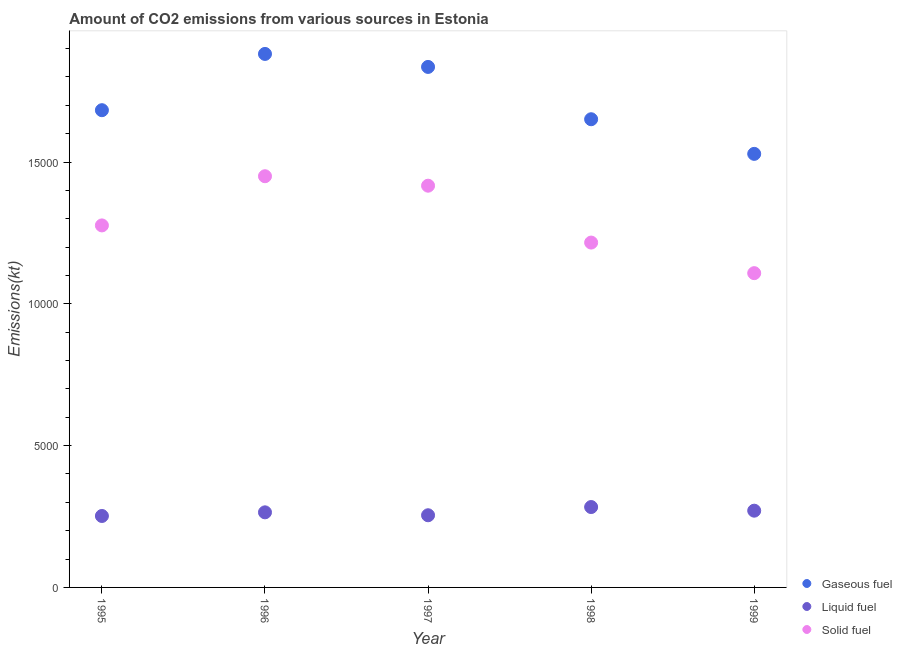What is the amount of co2 emissions from solid fuel in 1998?
Your answer should be very brief. 1.22e+04. Across all years, what is the maximum amount of co2 emissions from gaseous fuel?
Offer a very short reply. 1.88e+04. Across all years, what is the minimum amount of co2 emissions from gaseous fuel?
Make the answer very short. 1.53e+04. In which year was the amount of co2 emissions from liquid fuel maximum?
Offer a terse response. 1998. In which year was the amount of co2 emissions from gaseous fuel minimum?
Your response must be concise. 1999. What is the total amount of co2 emissions from liquid fuel in the graph?
Ensure brevity in your answer.  1.33e+04. What is the difference between the amount of co2 emissions from liquid fuel in 1995 and that in 1998?
Your response must be concise. -315.36. What is the difference between the amount of co2 emissions from liquid fuel in 1999 and the amount of co2 emissions from gaseous fuel in 1998?
Ensure brevity in your answer.  -1.38e+04. What is the average amount of co2 emissions from liquid fuel per year?
Your answer should be very brief. 2650.51. In the year 1997, what is the difference between the amount of co2 emissions from gaseous fuel and amount of co2 emissions from liquid fuel?
Your response must be concise. 1.58e+04. In how many years, is the amount of co2 emissions from liquid fuel greater than 8000 kt?
Your response must be concise. 0. What is the ratio of the amount of co2 emissions from liquid fuel in 1995 to that in 1996?
Offer a terse response. 0.95. Is the difference between the amount of co2 emissions from solid fuel in 1996 and 1999 greater than the difference between the amount of co2 emissions from gaseous fuel in 1996 and 1999?
Offer a very short reply. No. What is the difference between the highest and the second highest amount of co2 emissions from gaseous fuel?
Keep it short and to the point. 458.38. What is the difference between the highest and the lowest amount of co2 emissions from liquid fuel?
Give a very brief answer. 315.36. In how many years, is the amount of co2 emissions from liquid fuel greater than the average amount of co2 emissions from liquid fuel taken over all years?
Give a very brief answer. 2. Does the amount of co2 emissions from solid fuel monotonically increase over the years?
Keep it short and to the point. No. Is the amount of co2 emissions from liquid fuel strictly less than the amount of co2 emissions from solid fuel over the years?
Ensure brevity in your answer.  Yes. Are the values on the major ticks of Y-axis written in scientific E-notation?
Offer a terse response. No. Where does the legend appear in the graph?
Your response must be concise. Bottom right. How are the legend labels stacked?
Your response must be concise. Vertical. What is the title of the graph?
Keep it short and to the point. Amount of CO2 emissions from various sources in Estonia. Does "Resident buildings and public services" appear as one of the legend labels in the graph?
Offer a very short reply. No. What is the label or title of the Y-axis?
Keep it short and to the point. Emissions(kt). What is the Emissions(kt) of Gaseous fuel in 1995?
Your answer should be very brief. 1.68e+04. What is the Emissions(kt) of Liquid fuel in 1995?
Give a very brief answer. 2519.23. What is the Emissions(kt) in Solid fuel in 1995?
Offer a terse response. 1.28e+04. What is the Emissions(kt) of Gaseous fuel in 1996?
Your answer should be very brief. 1.88e+04. What is the Emissions(kt) in Liquid fuel in 1996?
Make the answer very short. 2647.57. What is the Emissions(kt) of Solid fuel in 1996?
Offer a very short reply. 1.45e+04. What is the Emissions(kt) in Gaseous fuel in 1997?
Make the answer very short. 1.84e+04. What is the Emissions(kt) of Liquid fuel in 1997?
Your answer should be compact. 2544.9. What is the Emissions(kt) in Solid fuel in 1997?
Provide a succinct answer. 1.42e+04. What is the Emissions(kt) of Gaseous fuel in 1998?
Provide a succinct answer. 1.65e+04. What is the Emissions(kt) of Liquid fuel in 1998?
Provide a succinct answer. 2834.59. What is the Emissions(kt) of Solid fuel in 1998?
Offer a very short reply. 1.22e+04. What is the Emissions(kt) of Gaseous fuel in 1999?
Make the answer very short. 1.53e+04. What is the Emissions(kt) in Liquid fuel in 1999?
Your answer should be compact. 2706.25. What is the Emissions(kt) in Solid fuel in 1999?
Offer a very short reply. 1.11e+04. Across all years, what is the maximum Emissions(kt) of Gaseous fuel?
Offer a very short reply. 1.88e+04. Across all years, what is the maximum Emissions(kt) of Liquid fuel?
Provide a succinct answer. 2834.59. Across all years, what is the maximum Emissions(kt) of Solid fuel?
Offer a very short reply. 1.45e+04. Across all years, what is the minimum Emissions(kt) in Gaseous fuel?
Your response must be concise. 1.53e+04. Across all years, what is the minimum Emissions(kt) in Liquid fuel?
Your answer should be very brief. 2519.23. Across all years, what is the minimum Emissions(kt) of Solid fuel?
Keep it short and to the point. 1.11e+04. What is the total Emissions(kt) of Gaseous fuel in the graph?
Make the answer very short. 8.58e+04. What is the total Emissions(kt) in Liquid fuel in the graph?
Your answer should be compact. 1.33e+04. What is the total Emissions(kt) in Solid fuel in the graph?
Provide a succinct answer. 6.47e+04. What is the difference between the Emissions(kt) of Gaseous fuel in 1995 and that in 1996?
Offer a terse response. -1983.85. What is the difference between the Emissions(kt) in Liquid fuel in 1995 and that in 1996?
Your response must be concise. -128.34. What is the difference between the Emissions(kt) in Solid fuel in 1995 and that in 1996?
Ensure brevity in your answer.  -1734.49. What is the difference between the Emissions(kt) in Gaseous fuel in 1995 and that in 1997?
Offer a very short reply. -1525.47. What is the difference between the Emissions(kt) of Liquid fuel in 1995 and that in 1997?
Offer a very short reply. -25.67. What is the difference between the Emissions(kt) of Solid fuel in 1995 and that in 1997?
Keep it short and to the point. -1400.79. What is the difference between the Emissions(kt) of Gaseous fuel in 1995 and that in 1998?
Ensure brevity in your answer.  319.03. What is the difference between the Emissions(kt) in Liquid fuel in 1995 and that in 1998?
Your response must be concise. -315.36. What is the difference between the Emissions(kt) of Solid fuel in 1995 and that in 1998?
Your answer should be very brief. 605.05. What is the difference between the Emissions(kt) of Gaseous fuel in 1995 and that in 1999?
Offer a terse response. 1540.14. What is the difference between the Emissions(kt) of Liquid fuel in 1995 and that in 1999?
Provide a succinct answer. -187.02. What is the difference between the Emissions(kt) in Solid fuel in 1995 and that in 1999?
Your answer should be compact. 1683.15. What is the difference between the Emissions(kt) in Gaseous fuel in 1996 and that in 1997?
Keep it short and to the point. 458.38. What is the difference between the Emissions(kt) of Liquid fuel in 1996 and that in 1997?
Provide a succinct answer. 102.68. What is the difference between the Emissions(kt) of Solid fuel in 1996 and that in 1997?
Ensure brevity in your answer.  333.7. What is the difference between the Emissions(kt) of Gaseous fuel in 1996 and that in 1998?
Provide a succinct answer. 2302.88. What is the difference between the Emissions(kt) in Liquid fuel in 1996 and that in 1998?
Make the answer very short. -187.02. What is the difference between the Emissions(kt) in Solid fuel in 1996 and that in 1998?
Offer a terse response. 2339.55. What is the difference between the Emissions(kt) of Gaseous fuel in 1996 and that in 1999?
Your response must be concise. 3523.99. What is the difference between the Emissions(kt) in Liquid fuel in 1996 and that in 1999?
Your response must be concise. -58.67. What is the difference between the Emissions(kt) in Solid fuel in 1996 and that in 1999?
Provide a succinct answer. 3417.64. What is the difference between the Emissions(kt) of Gaseous fuel in 1997 and that in 1998?
Your answer should be very brief. 1844.5. What is the difference between the Emissions(kt) in Liquid fuel in 1997 and that in 1998?
Provide a short and direct response. -289.69. What is the difference between the Emissions(kt) of Solid fuel in 1997 and that in 1998?
Give a very brief answer. 2005.85. What is the difference between the Emissions(kt) of Gaseous fuel in 1997 and that in 1999?
Your response must be concise. 3065.61. What is the difference between the Emissions(kt) in Liquid fuel in 1997 and that in 1999?
Ensure brevity in your answer.  -161.35. What is the difference between the Emissions(kt) in Solid fuel in 1997 and that in 1999?
Your answer should be compact. 3083.95. What is the difference between the Emissions(kt) in Gaseous fuel in 1998 and that in 1999?
Offer a terse response. 1221.11. What is the difference between the Emissions(kt) of Liquid fuel in 1998 and that in 1999?
Your answer should be very brief. 128.34. What is the difference between the Emissions(kt) of Solid fuel in 1998 and that in 1999?
Make the answer very short. 1078.1. What is the difference between the Emissions(kt) in Gaseous fuel in 1995 and the Emissions(kt) in Liquid fuel in 1996?
Give a very brief answer. 1.42e+04. What is the difference between the Emissions(kt) of Gaseous fuel in 1995 and the Emissions(kt) of Solid fuel in 1996?
Make the answer very short. 2328.55. What is the difference between the Emissions(kt) of Liquid fuel in 1995 and the Emissions(kt) of Solid fuel in 1996?
Your answer should be very brief. -1.20e+04. What is the difference between the Emissions(kt) of Gaseous fuel in 1995 and the Emissions(kt) of Liquid fuel in 1997?
Your response must be concise. 1.43e+04. What is the difference between the Emissions(kt) of Gaseous fuel in 1995 and the Emissions(kt) of Solid fuel in 1997?
Keep it short and to the point. 2662.24. What is the difference between the Emissions(kt) in Liquid fuel in 1995 and the Emissions(kt) in Solid fuel in 1997?
Your answer should be very brief. -1.16e+04. What is the difference between the Emissions(kt) in Gaseous fuel in 1995 and the Emissions(kt) in Liquid fuel in 1998?
Your response must be concise. 1.40e+04. What is the difference between the Emissions(kt) of Gaseous fuel in 1995 and the Emissions(kt) of Solid fuel in 1998?
Give a very brief answer. 4668.09. What is the difference between the Emissions(kt) in Liquid fuel in 1995 and the Emissions(kt) in Solid fuel in 1998?
Offer a terse response. -9640.54. What is the difference between the Emissions(kt) in Gaseous fuel in 1995 and the Emissions(kt) in Liquid fuel in 1999?
Your response must be concise. 1.41e+04. What is the difference between the Emissions(kt) of Gaseous fuel in 1995 and the Emissions(kt) of Solid fuel in 1999?
Keep it short and to the point. 5746.19. What is the difference between the Emissions(kt) in Liquid fuel in 1995 and the Emissions(kt) in Solid fuel in 1999?
Your answer should be very brief. -8562.44. What is the difference between the Emissions(kt) of Gaseous fuel in 1996 and the Emissions(kt) of Liquid fuel in 1997?
Your response must be concise. 1.63e+04. What is the difference between the Emissions(kt) of Gaseous fuel in 1996 and the Emissions(kt) of Solid fuel in 1997?
Your response must be concise. 4646.09. What is the difference between the Emissions(kt) of Liquid fuel in 1996 and the Emissions(kt) of Solid fuel in 1997?
Your answer should be compact. -1.15e+04. What is the difference between the Emissions(kt) of Gaseous fuel in 1996 and the Emissions(kt) of Liquid fuel in 1998?
Provide a succinct answer. 1.60e+04. What is the difference between the Emissions(kt) in Gaseous fuel in 1996 and the Emissions(kt) in Solid fuel in 1998?
Ensure brevity in your answer.  6651.94. What is the difference between the Emissions(kt) of Liquid fuel in 1996 and the Emissions(kt) of Solid fuel in 1998?
Give a very brief answer. -9512.2. What is the difference between the Emissions(kt) in Gaseous fuel in 1996 and the Emissions(kt) in Liquid fuel in 1999?
Keep it short and to the point. 1.61e+04. What is the difference between the Emissions(kt) in Gaseous fuel in 1996 and the Emissions(kt) in Solid fuel in 1999?
Provide a succinct answer. 7730.04. What is the difference between the Emissions(kt) in Liquid fuel in 1996 and the Emissions(kt) in Solid fuel in 1999?
Give a very brief answer. -8434.1. What is the difference between the Emissions(kt) of Gaseous fuel in 1997 and the Emissions(kt) of Liquid fuel in 1998?
Your response must be concise. 1.55e+04. What is the difference between the Emissions(kt) of Gaseous fuel in 1997 and the Emissions(kt) of Solid fuel in 1998?
Give a very brief answer. 6193.56. What is the difference between the Emissions(kt) in Liquid fuel in 1997 and the Emissions(kt) in Solid fuel in 1998?
Your answer should be compact. -9614.87. What is the difference between the Emissions(kt) of Gaseous fuel in 1997 and the Emissions(kt) of Liquid fuel in 1999?
Keep it short and to the point. 1.56e+04. What is the difference between the Emissions(kt) of Gaseous fuel in 1997 and the Emissions(kt) of Solid fuel in 1999?
Give a very brief answer. 7271.66. What is the difference between the Emissions(kt) of Liquid fuel in 1997 and the Emissions(kt) of Solid fuel in 1999?
Make the answer very short. -8536.78. What is the difference between the Emissions(kt) in Gaseous fuel in 1998 and the Emissions(kt) in Liquid fuel in 1999?
Offer a very short reply. 1.38e+04. What is the difference between the Emissions(kt) of Gaseous fuel in 1998 and the Emissions(kt) of Solid fuel in 1999?
Ensure brevity in your answer.  5427.16. What is the difference between the Emissions(kt) in Liquid fuel in 1998 and the Emissions(kt) in Solid fuel in 1999?
Provide a short and direct response. -8247.08. What is the average Emissions(kt) of Gaseous fuel per year?
Offer a terse response. 1.72e+04. What is the average Emissions(kt) of Liquid fuel per year?
Your answer should be compact. 2650.51. What is the average Emissions(kt) in Solid fuel per year?
Your response must be concise. 1.29e+04. In the year 1995, what is the difference between the Emissions(kt) of Gaseous fuel and Emissions(kt) of Liquid fuel?
Provide a succinct answer. 1.43e+04. In the year 1995, what is the difference between the Emissions(kt) in Gaseous fuel and Emissions(kt) in Solid fuel?
Your answer should be compact. 4063.04. In the year 1995, what is the difference between the Emissions(kt) of Liquid fuel and Emissions(kt) of Solid fuel?
Your response must be concise. -1.02e+04. In the year 1996, what is the difference between the Emissions(kt) in Gaseous fuel and Emissions(kt) in Liquid fuel?
Ensure brevity in your answer.  1.62e+04. In the year 1996, what is the difference between the Emissions(kt) in Gaseous fuel and Emissions(kt) in Solid fuel?
Offer a terse response. 4312.39. In the year 1996, what is the difference between the Emissions(kt) of Liquid fuel and Emissions(kt) of Solid fuel?
Ensure brevity in your answer.  -1.19e+04. In the year 1997, what is the difference between the Emissions(kt) of Gaseous fuel and Emissions(kt) of Liquid fuel?
Provide a short and direct response. 1.58e+04. In the year 1997, what is the difference between the Emissions(kt) in Gaseous fuel and Emissions(kt) in Solid fuel?
Offer a terse response. 4187.71. In the year 1997, what is the difference between the Emissions(kt) of Liquid fuel and Emissions(kt) of Solid fuel?
Offer a terse response. -1.16e+04. In the year 1998, what is the difference between the Emissions(kt) in Gaseous fuel and Emissions(kt) in Liquid fuel?
Keep it short and to the point. 1.37e+04. In the year 1998, what is the difference between the Emissions(kt) of Gaseous fuel and Emissions(kt) of Solid fuel?
Provide a short and direct response. 4349.06. In the year 1998, what is the difference between the Emissions(kt) of Liquid fuel and Emissions(kt) of Solid fuel?
Make the answer very short. -9325.18. In the year 1999, what is the difference between the Emissions(kt) in Gaseous fuel and Emissions(kt) in Liquid fuel?
Your answer should be compact. 1.26e+04. In the year 1999, what is the difference between the Emissions(kt) in Gaseous fuel and Emissions(kt) in Solid fuel?
Provide a short and direct response. 4206.05. In the year 1999, what is the difference between the Emissions(kt) of Liquid fuel and Emissions(kt) of Solid fuel?
Ensure brevity in your answer.  -8375.43. What is the ratio of the Emissions(kt) of Gaseous fuel in 1995 to that in 1996?
Your response must be concise. 0.89. What is the ratio of the Emissions(kt) of Liquid fuel in 1995 to that in 1996?
Your answer should be compact. 0.95. What is the ratio of the Emissions(kt) of Solid fuel in 1995 to that in 1996?
Offer a terse response. 0.88. What is the ratio of the Emissions(kt) in Gaseous fuel in 1995 to that in 1997?
Give a very brief answer. 0.92. What is the ratio of the Emissions(kt) in Liquid fuel in 1995 to that in 1997?
Keep it short and to the point. 0.99. What is the ratio of the Emissions(kt) in Solid fuel in 1995 to that in 1997?
Provide a short and direct response. 0.9. What is the ratio of the Emissions(kt) of Gaseous fuel in 1995 to that in 1998?
Provide a short and direct response. 1.02. What is the ratio of the Emissions(kt) in Liquid fuel in 1995 to that in 1998?
Your answer should be very brief. 0.89. What is the ratio of the Emissions(kt) in Solid fuel in 1995 to that in 1998?
Ensure brevity in your answer.  1.05. What is the ratio of the Emissions(kt) of Gaseous fuel in 1995 to that in 1999?
Provide a succinct answer. 1.1. What is the ratio of the Emissions(kt) of Liquid fuel in 1995 to that in 1999?
Ensure brevity in your answer.  0.93. What is the ratio of the Emissions(kt) of Solid fuel in 1995 to that in 1999?
Keep it short and to the point. 1.15. What is the ratio of the Emissions(kt) in Liquid fuel in 1996 to that in 1997?
Give a very brief answer. 1.04. What is the ratio of the Emissions(kt) of Solid fuel in 1996 to that in 1997?
Offer a very short reply. 1.02. What is the ratio of the Emissions(kt) in Gaseous fuel in 1996 to that in 1998?
Make the answer very short. 1.14. What is the ratio of the Emissions(kt) of Liquid fuel in 1996 to that in 1998?
Provide a succinct answer. 0.93. What is the ratio of the Emissions(kt) of Solid fuel in 1996 to that in 1998?
Provide a succinct answer. 1.19. What is the ratio of the Emissions(kt) of Gaseous fuel in 1996 to that in 1999?
Provide a short and direct response. 1.23. What is the ratio of the Emissions(kt) of Liquid fuel in 1996 to that in 1999?
Make the answer very short. 0.98. What is the ratio of the Emissions(kt) in Solid fuel in 1996 to that in 1999?
Your answer should be very brief. 1.31. What is the ratio of the Emissions(kt) in Gaseous fuel in 1997 to that in 1998?
Your response must be concise. 1.11. What is the ratio of the Emissions(kt) in Liquid fuel in 1997 to that in 1998?
Provide a short and direct response. 0.9. What is the ratio of the Emissions(kt) in Solid fuel in 1997 to that in 1998?
Make the answer very short. 1.17. What is the ratio of the Emissions(kt) in Gaseous fuel in 1997 to that in 1999?
Your answer should be very brief. 1.2. What is the ratio of the Emissions(kt) of Liquid fuel in 1997 to that in 1999?
Make the answer very short. 0.94. What is the ratio of the Emissions(kt) in Solid fuel in 1997 to that in 1999?
Provide a short and direct response. 1.28. What is the ratio of the Emissions(kt) in Gaseous fuel in 1998 to that in 1999?
Your response must be concise. 1.08. What is the ratio of the Emissions(kt) in Liquid fuel in 1998 to that in 1999?
Give a very brief answer. 1.05. What is the ratio of the Emissions(kt) of Solid fuel in 1998 to that in 1999?
Keep it short and to the point. 1.1. What is the difference between the highest and the second highest Emissions(kt) in Gaseous fuel?
Offer a very short reply. 458.38. What is the difference between the highest and the second highest Emissions(kt) in Liquid fuel?
Ensure brevity in your answer.  128.34. What is the difference between the highest and the second highest Emissions(kt) in Solid fuel?
Ensure brevity in your answer.  333.7. What is the difference between the highest and the lowest Emissions(kt) of Gaseous fuel?
Provide a succinct answer. 3523.99. What is the difference between the highest and the lowest Emissions(kt) of Liquid fuel?
Your response must be concise. 315.36. What is the difference between the highest and the lowest Emissions(kt) in Solid fuel?
Offer a terse response. 3417.64. 